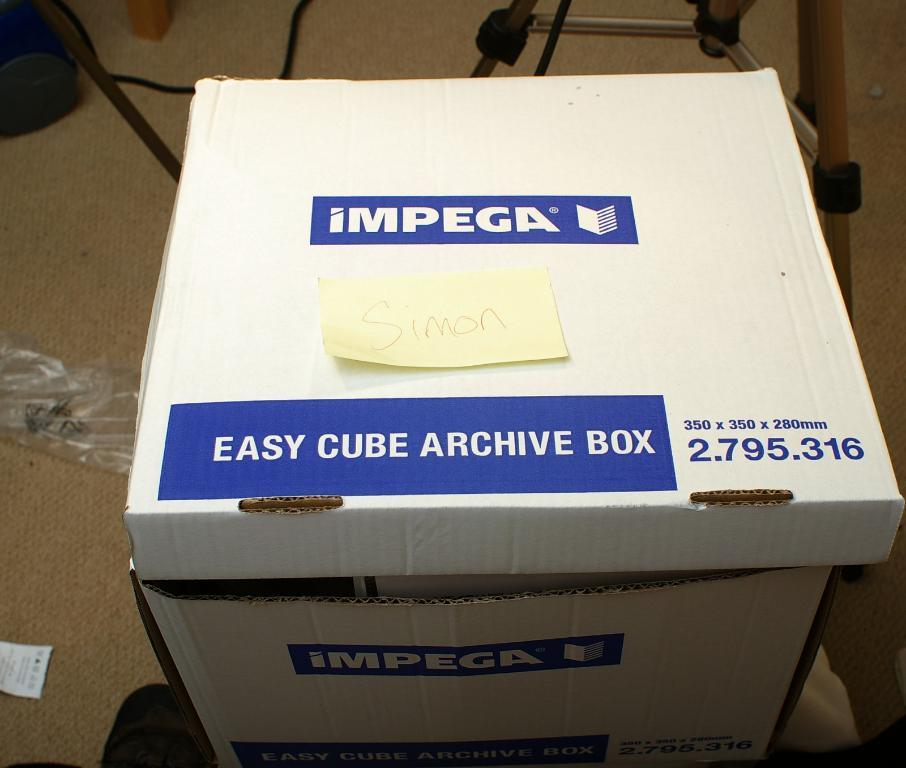<image>
Provide a brief description of the given image. A blue and white cardboard box with easy cube archive box printed on it. 